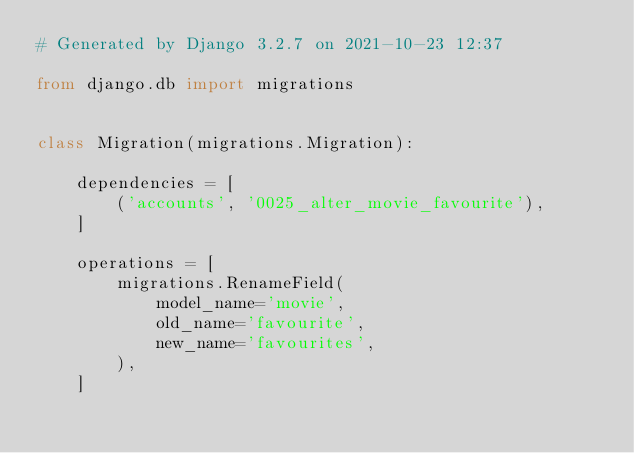Convert code to text. <code><loc_0><loc_0><loc_500><loc_500><_Python_># Generated by Django 3.2.7 on 2021-10-23 12:37

from django.db import migrations


class Migration(migrations.Migration):

    dependencies = [
        ('accounts', '0025_alter_movie_favourite'),
    ]

    operations = [
        migrations.RenameField(
            model_name='movie',
            old_name='favourite',
            new_name='favourites',
        ),
    ]
</code> 